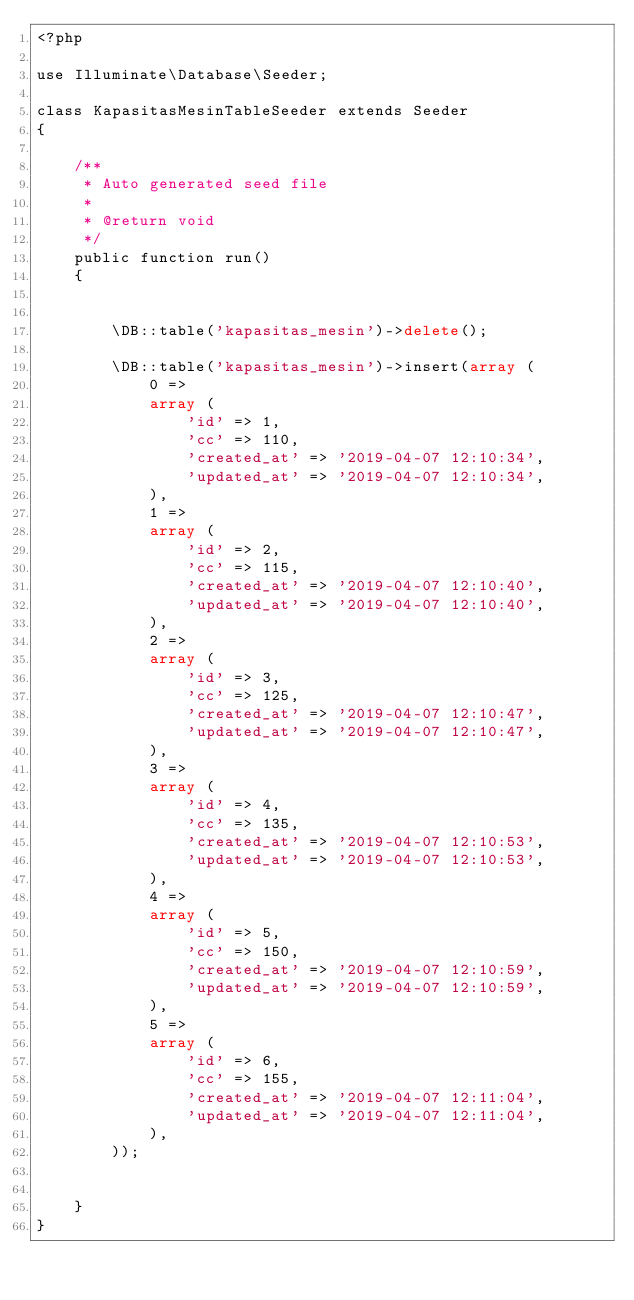<code> <loc_0><loc_0><loc_500><loc_500><_PHP_><?php

use Illuminate\Database\Seeder;

class KapasitasMesinTableSeeder extends Seeder
{

    /**
     * Auto generated seed file
     *
     * @return void
     */
    public function run()
    {
        

        \DB::table('kapasitas_mesin')->delete();
        
        \DB::table('kapasitas_mesin')->insert(array (
            0 => 
            array (
                'id' => 1,
                'cc' => 110,
                'created_at' => '2019-04-07 12:10:34',
                'updated_at' => '2019-04-07 12:10:34',
            ),
            1 => 
            array (
                'id' => 2,
                'cc' => 115,
                'created_at' => '2019-04-07 12:10:40',
                'updated_at' => '2019-04-07 12:10:40',
            ),
            2 => 
            array (
                'id' => 3,
                'cc' => 125,
                'created_at' => '2019-04-07 12:10:47',
                'updated_at' => '2019-04-07 12:10:47',
            ),
            3 => 
            array (
                'id' => 4,
                'cc' => 135,
                'created_at' => '2019-04-07 12:10:53',
                'updated_at' => '2019-04-07 12:10:53',
            ),
            4 => 
            array (
                'id' => 5,
                'cc' => 150,
                'created_at' => '2019-04-07 12:10:59',
                'updated_at' => '2019-04-07 12:10:59',
            ),
            5 => 
            array (
                'id' => 6,
                'cc' => 155,
                'created_at' => '2019-04-07 12:11:04',
                'updated_at' => '2019-04-07 12:11:04',
            ),
        ));
        
        
    }
}</code> 